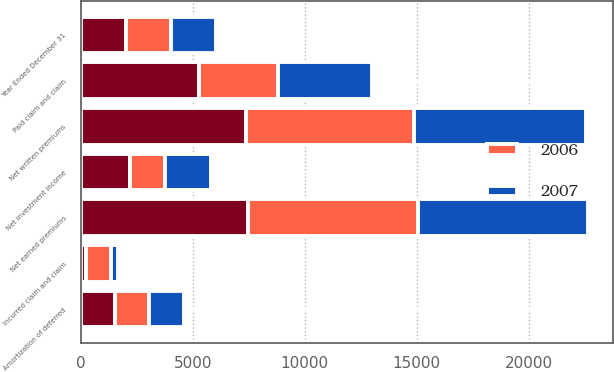Convert chart to OTSL. <chart><loc_0><loc_0><loc_500><loc_500><stacked_bar_chart><ecel><fcel>Year Ended December 31<fcel>Net written premiums<fcel>Net earned premiums<fcel>Net investment income<fcel>Incurred claim and claim<fcel>Amortization of deferred<fcel>Paid claim and claim<nl><fcel>nan<fcel>2007<fcel>7382<fcel>7481<fcel>2180<fcel>220<fcel>1520<fcel>5282<nl><fcel>2007<fcel>2006<fcel>7655<fcel>7595<fcel>2035<fcel>332<fcel>1534<fcel>4165<nl><fcel>2006<fcel>2005<fcel>7509<fcel>7558<fcel>1595<fcel>1107<fcel>1541<fcel>3541<nl></chart> 